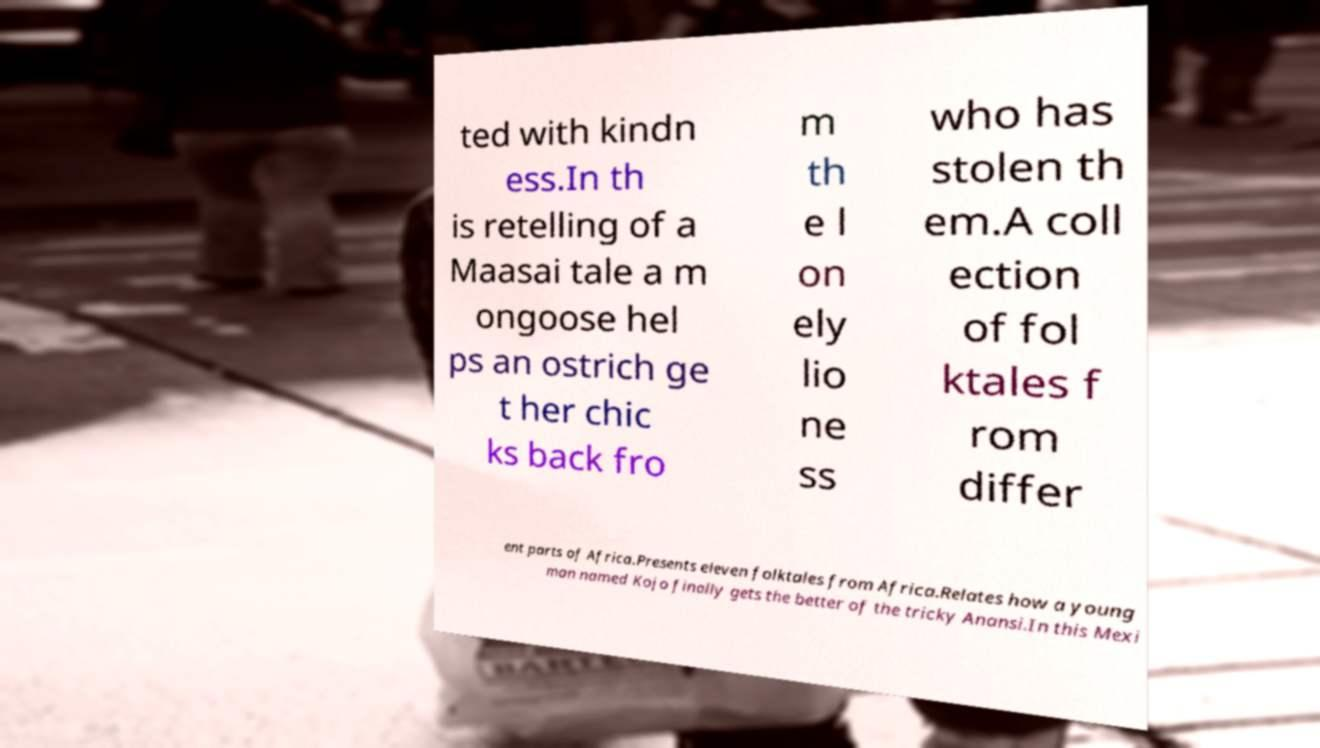Please read and relay the text visible in this image. What does it say? ted with kindn ess.In th is retelling of a Maasai tale a m ongoose hel ps an ostrich ge t her chic ks back fro m th e l on ely lio ne ss who has stolen th em.A coll ection of fol ktales f rom differ ent parts of Africa.Presents eleven folktales from Africa.Relates how a young man named Kojo finally gets the better of the tricky Anansi.In this Mexi 